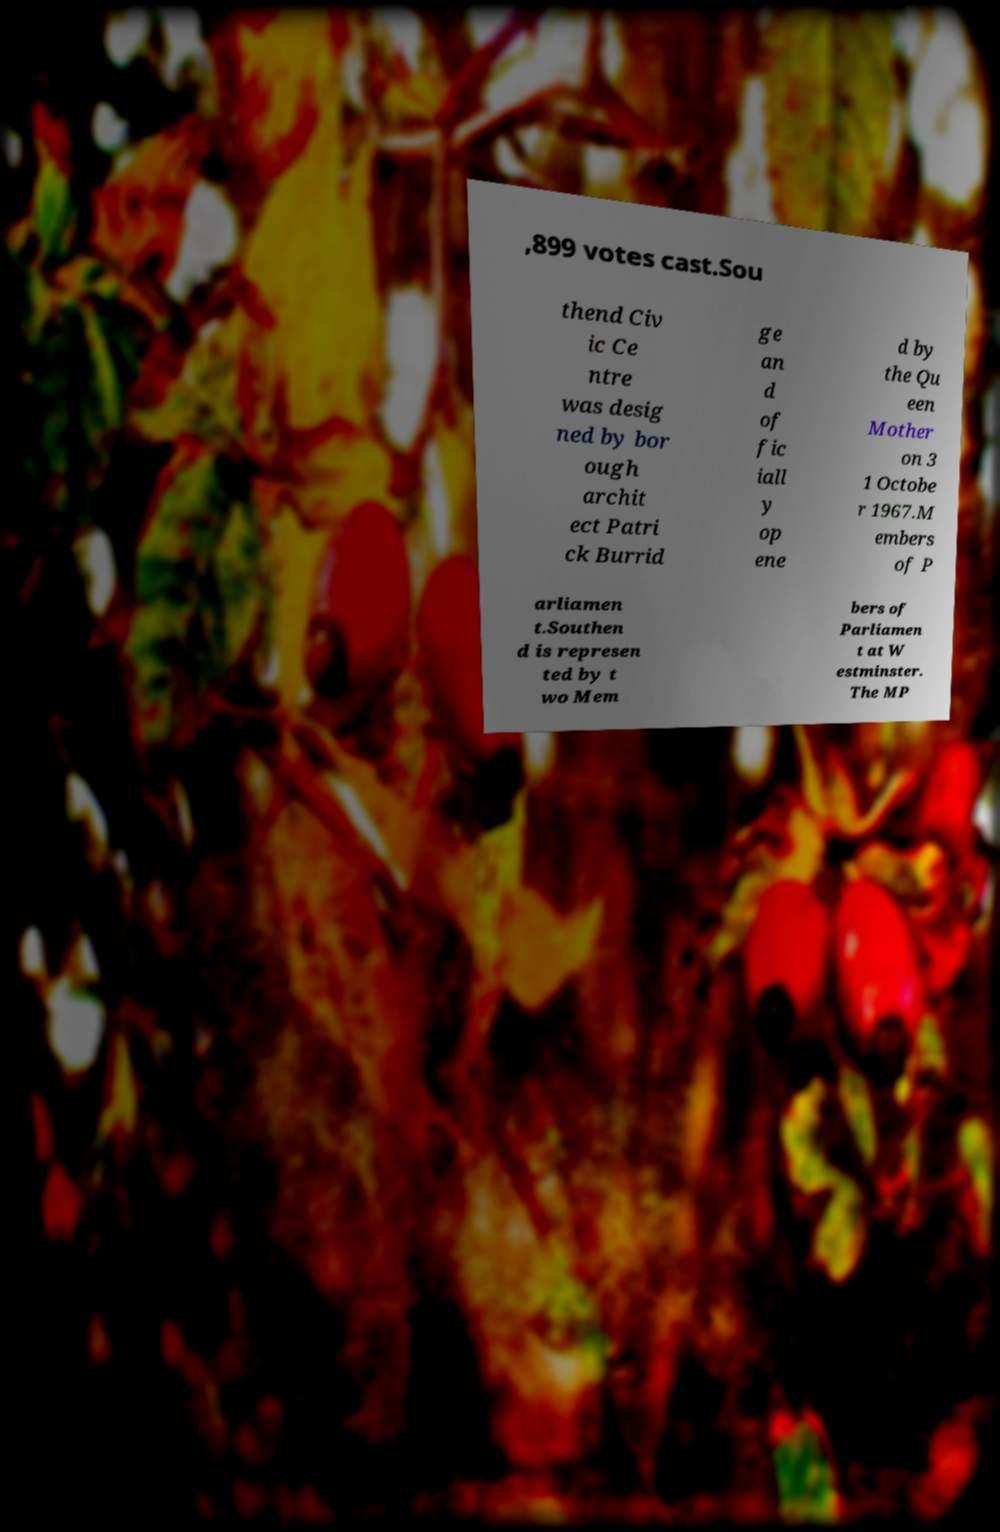What messages or text are displayed in this image? I need them in a readable, typed format. ,899 votes cast.Sou thend Civ ic Ce ntre was desig ned by bor ough archit ect Patri ck Burrid ge an d of fic iall y op ene d by the Qu een Mother on 3 1 Octobe r 1967.M embers of P arliamen t.Southen d is represen ted by t wo Mem bers of Parliamen t at W estminster. The MP 